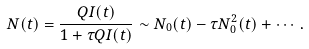Convert formula to latex. <formula><loc_0><loc_0><loc_500><loc_500>N ( t ) = \frac { Q I ( t ) } { 1 + \tau Q I ( t ) } \sim N _ { 0 } ( t ) - \tau N _ { 0 } ^ { 2 } ( t ) + \cdots .</formula> 